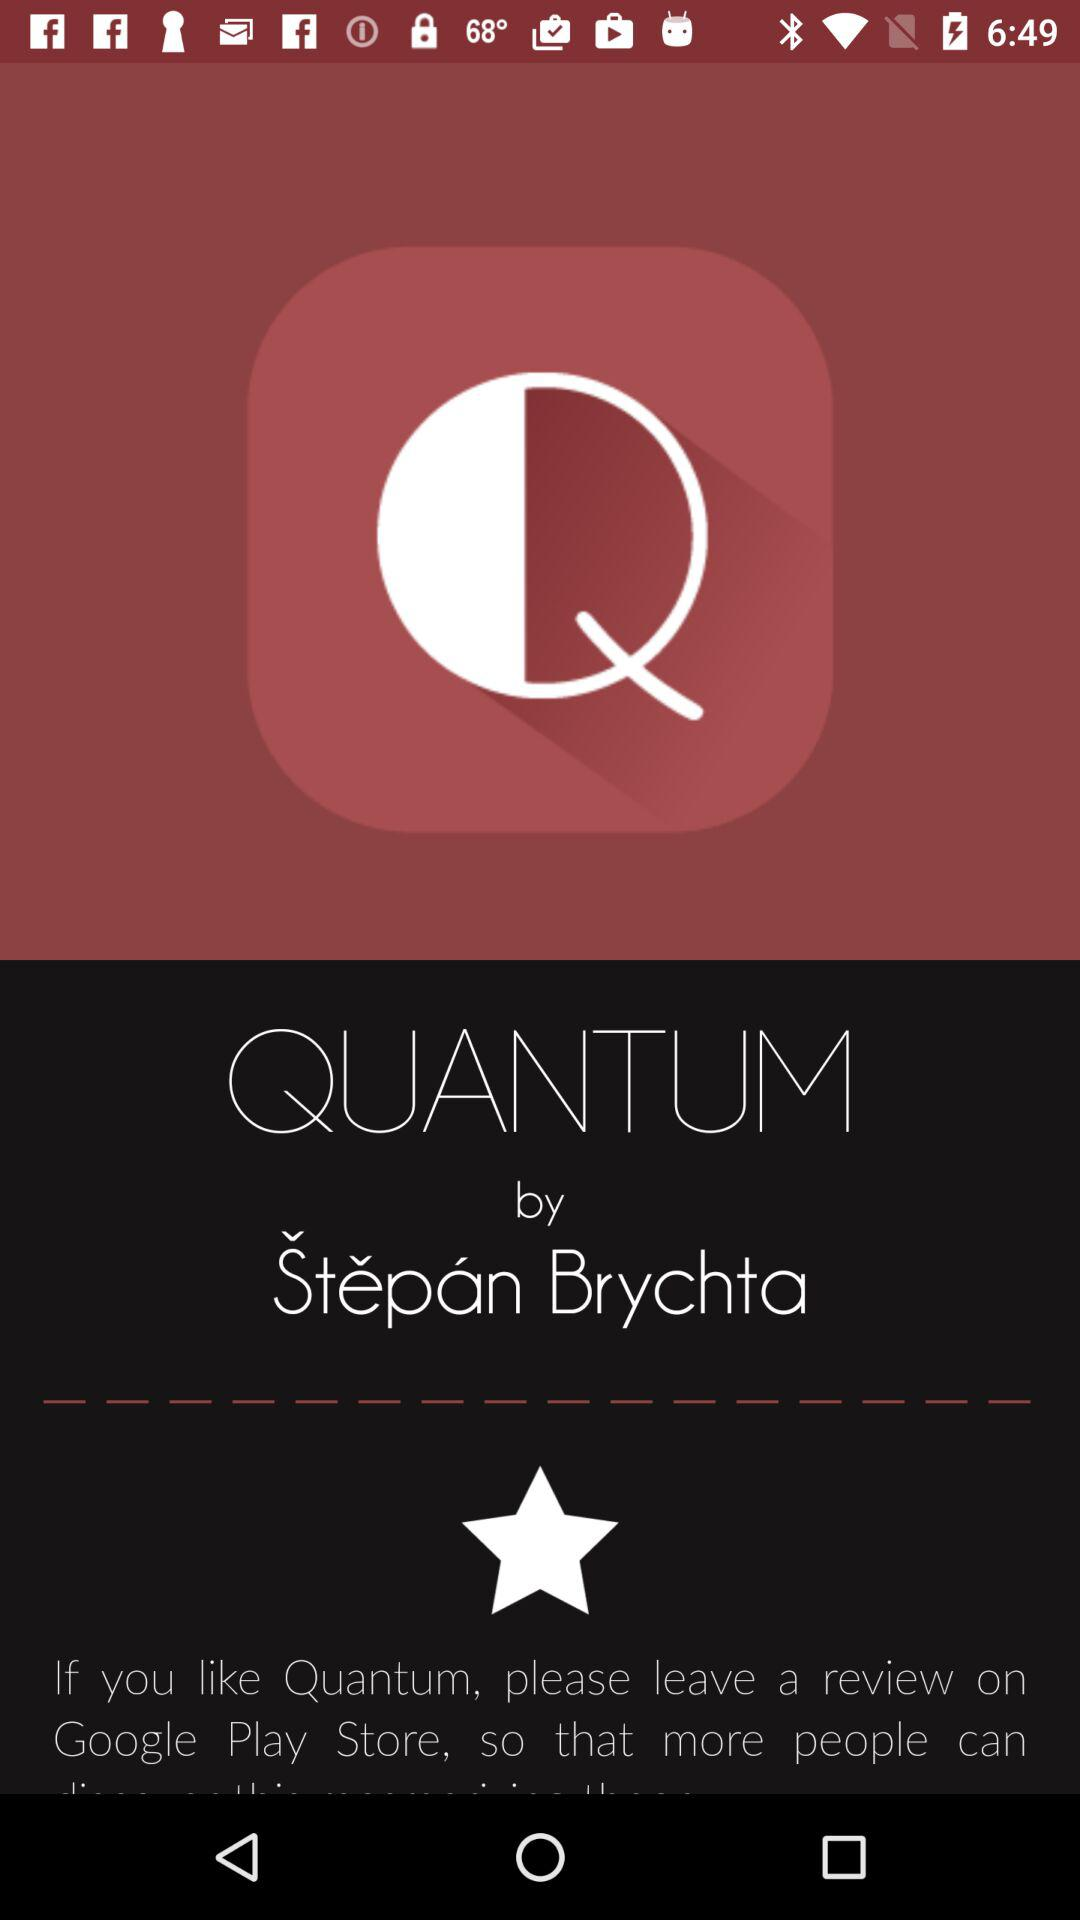Who is the author of Quantum? The author of Quantum is Stepan Brychta. 